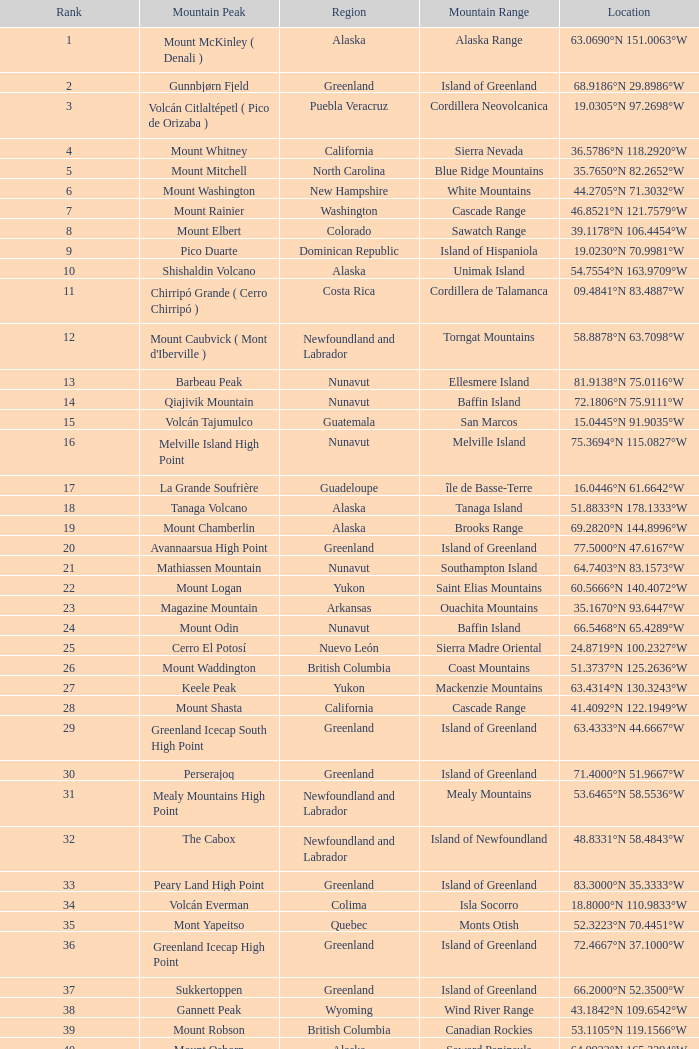2206°w? Isla Cedros High Point. 